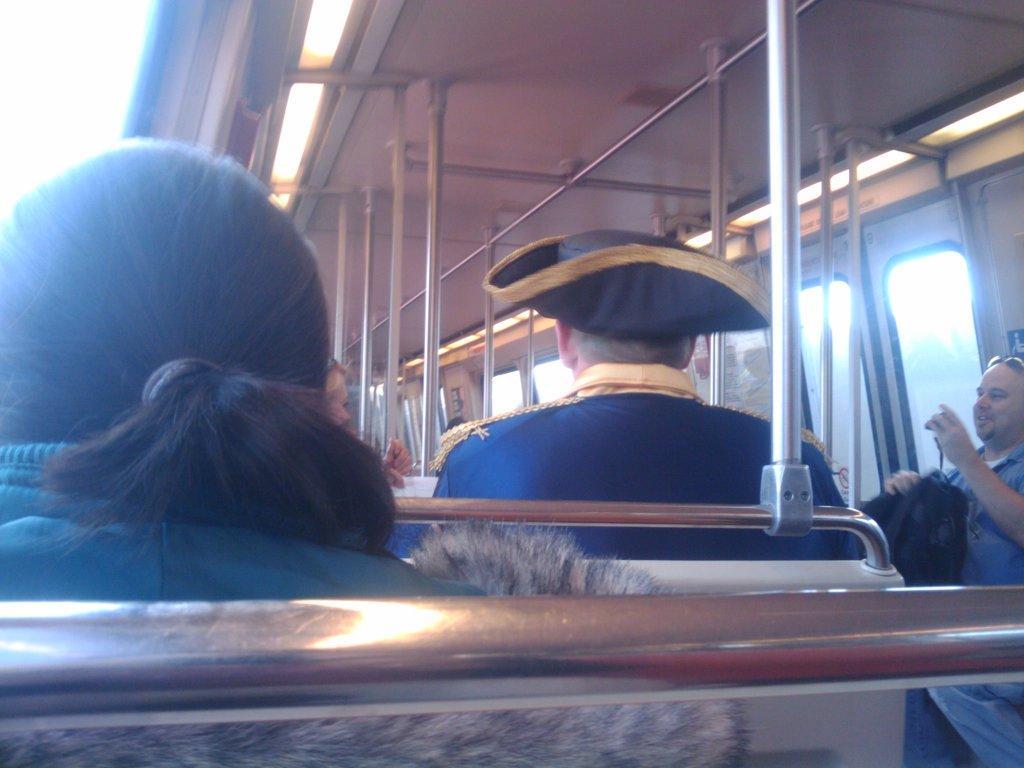In one or two sentences, can you explain what this image depicts? In this image there are people sitting in a bus and there are rods on the top there is a sheet and lights. 